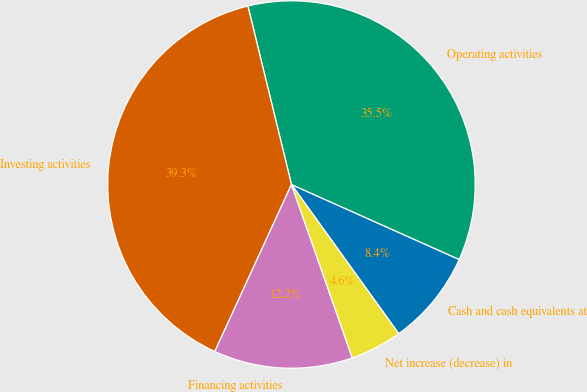<chart> <loc_0><loc_0><loc_500><loc_500><pie_chart><fcel>Cash and cash equivalents at<fcel>Operating activities<fcel>Investing activities<fcel>Financing activities<fcel>Net increase (decrease) in<nl><fcel>8.39%<fcel>35.5%<fcel>39.34%<fcel>12.22%<fcel>4.55%<nl></chart> 